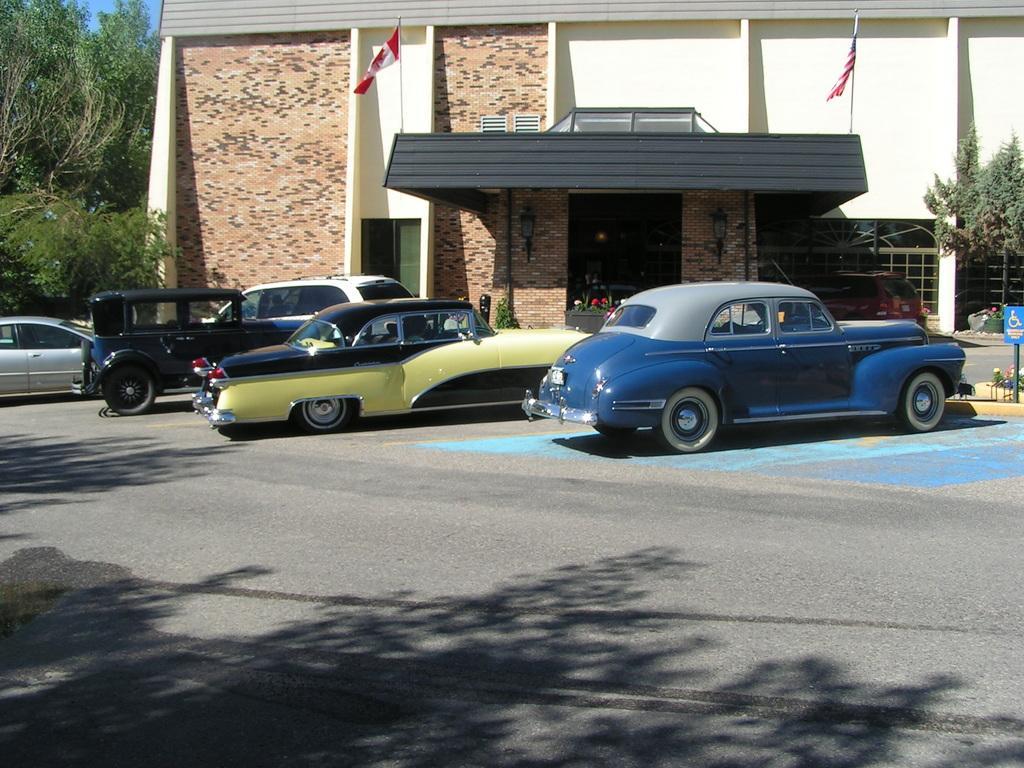Please provide a concise description of this image. This image consists of many cars parked on the road. At the bottom, there is a road. In the background, there is a building along with the trees. 